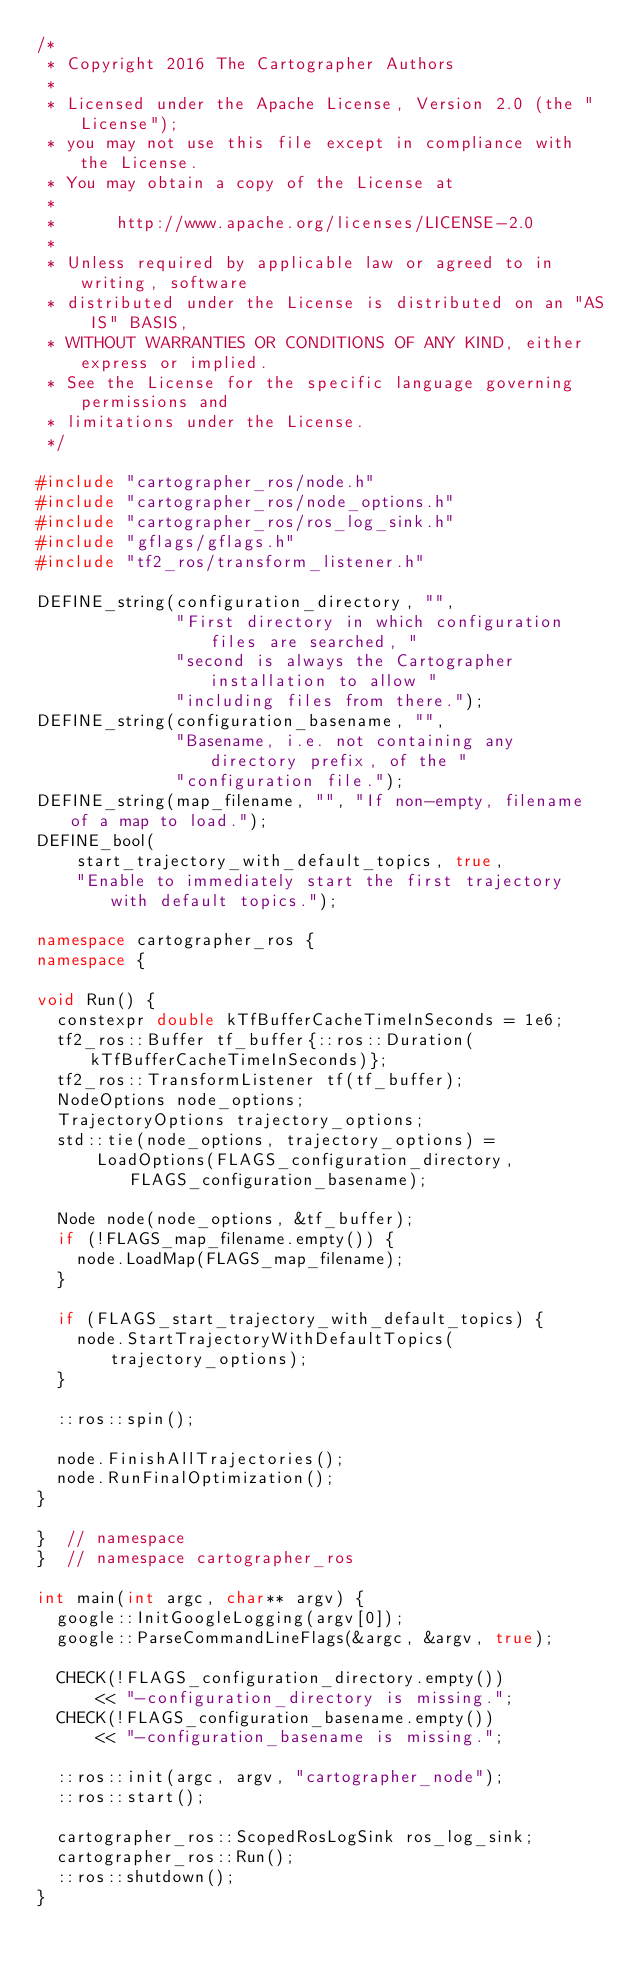<code> <loc_0><loc_0><loc_500><loc_500><_C++_>/*
 * Copyright 2016 The Cartographer Authors
 *
 * Licensed under the Apache License, Version 2.0 (the "License");
 * you may not use this file except in compliance with the License.
 * You may obtain a copy of the License at
 *
 *      http://www.apache.org/licenses/LICENSE-2.0
 *
 * Unless required by applicable law or agreed to in writing, software
 * distributed under the License is distributed on an "AS IS" BASIS,
 * WITHOUT WARRANTIES OR CONDITIONS OF ANY KIND, either express or implied.
 * See the License for the specific language governing permissions and
 * limitations under the License.
 */

#include "cartographer_ros/node.h"
#include "cartographer_ros/node_options.h"
#include "cartographer_ros/ros_log_sink.h"
#include "gflags/gflags.h"
#include "tf2_ros/transform_listener.h"

DEFINE_string(configuration_directory, "",
              "First directory in which configuration files are searched, "
              "second is always the Cartographer installation to allow "
              "including files from there.");
DEFINE_string(configuration_basename, "",
              "Basename, i.e. not containing any directory prefix, of the "
              "configuration file.");
DEFINE_string(map_filename, "", "If non-empty, filename of a map to load.");
DEFINE_bool(
    start_trajectory_with_default_topics, true,
    "Enable to immediately start the first trajectory with default topics.");

namespace cartographer_ros {
namespace {

void Run() {
  constexpr double kTfBufferCacheTimeInSeconds = 1e6;
  tf2_ros::Buffer tf_buffer{::ros::Duration(kTfBufferCacheTimeInSeconds)};
  tf2_ros::TransformListener tf(tf_buffer);
  NodeOptions node_options;
  TrajectoryOptions trajectory_options;
  std::tie(node_options, trajectory_options) =
      LoadOptions(FLAGS_configuration_directory, FLAGS_configuration_basename);

  Node node(node_options, &tf_buffer);
  if (!FLAGS_map_filename.empty()) {
    node.LoadMap(FLAGS_map_filename);
  }

  if (FLAGS_start_trajectory_with_default_topics) {
    node.StartTrajectoryWithDefaultTopics(trajectory_options);
  }

  ::ros::spin();

  node.FinishAllTrajectories();
  node.RunFinalOptimization();
}

}  // namespace
}  // namespace cartographer_ros

int main(int argc, char** argv) {
  google::InitGoogleLogging(argv[0]);
  google::ParseCommandLineFlags(&argc, &argv, true);

  CHECK(!FLAGS_configuration_directory.empty())
      << "-configuration_directory is missing.";
  CHECK(!FLAGS_configuration_basename.empty())
      << "-configuration_basename is missing.";

  ::ros::init(argc, argv, "cartographer_node");
  ::ros::start();

  cartographer_ros::ScopedRosLogSink ros_log_sink;
  cartographer_ros::Run();
  ::ros::shutdown();
}
</code> 